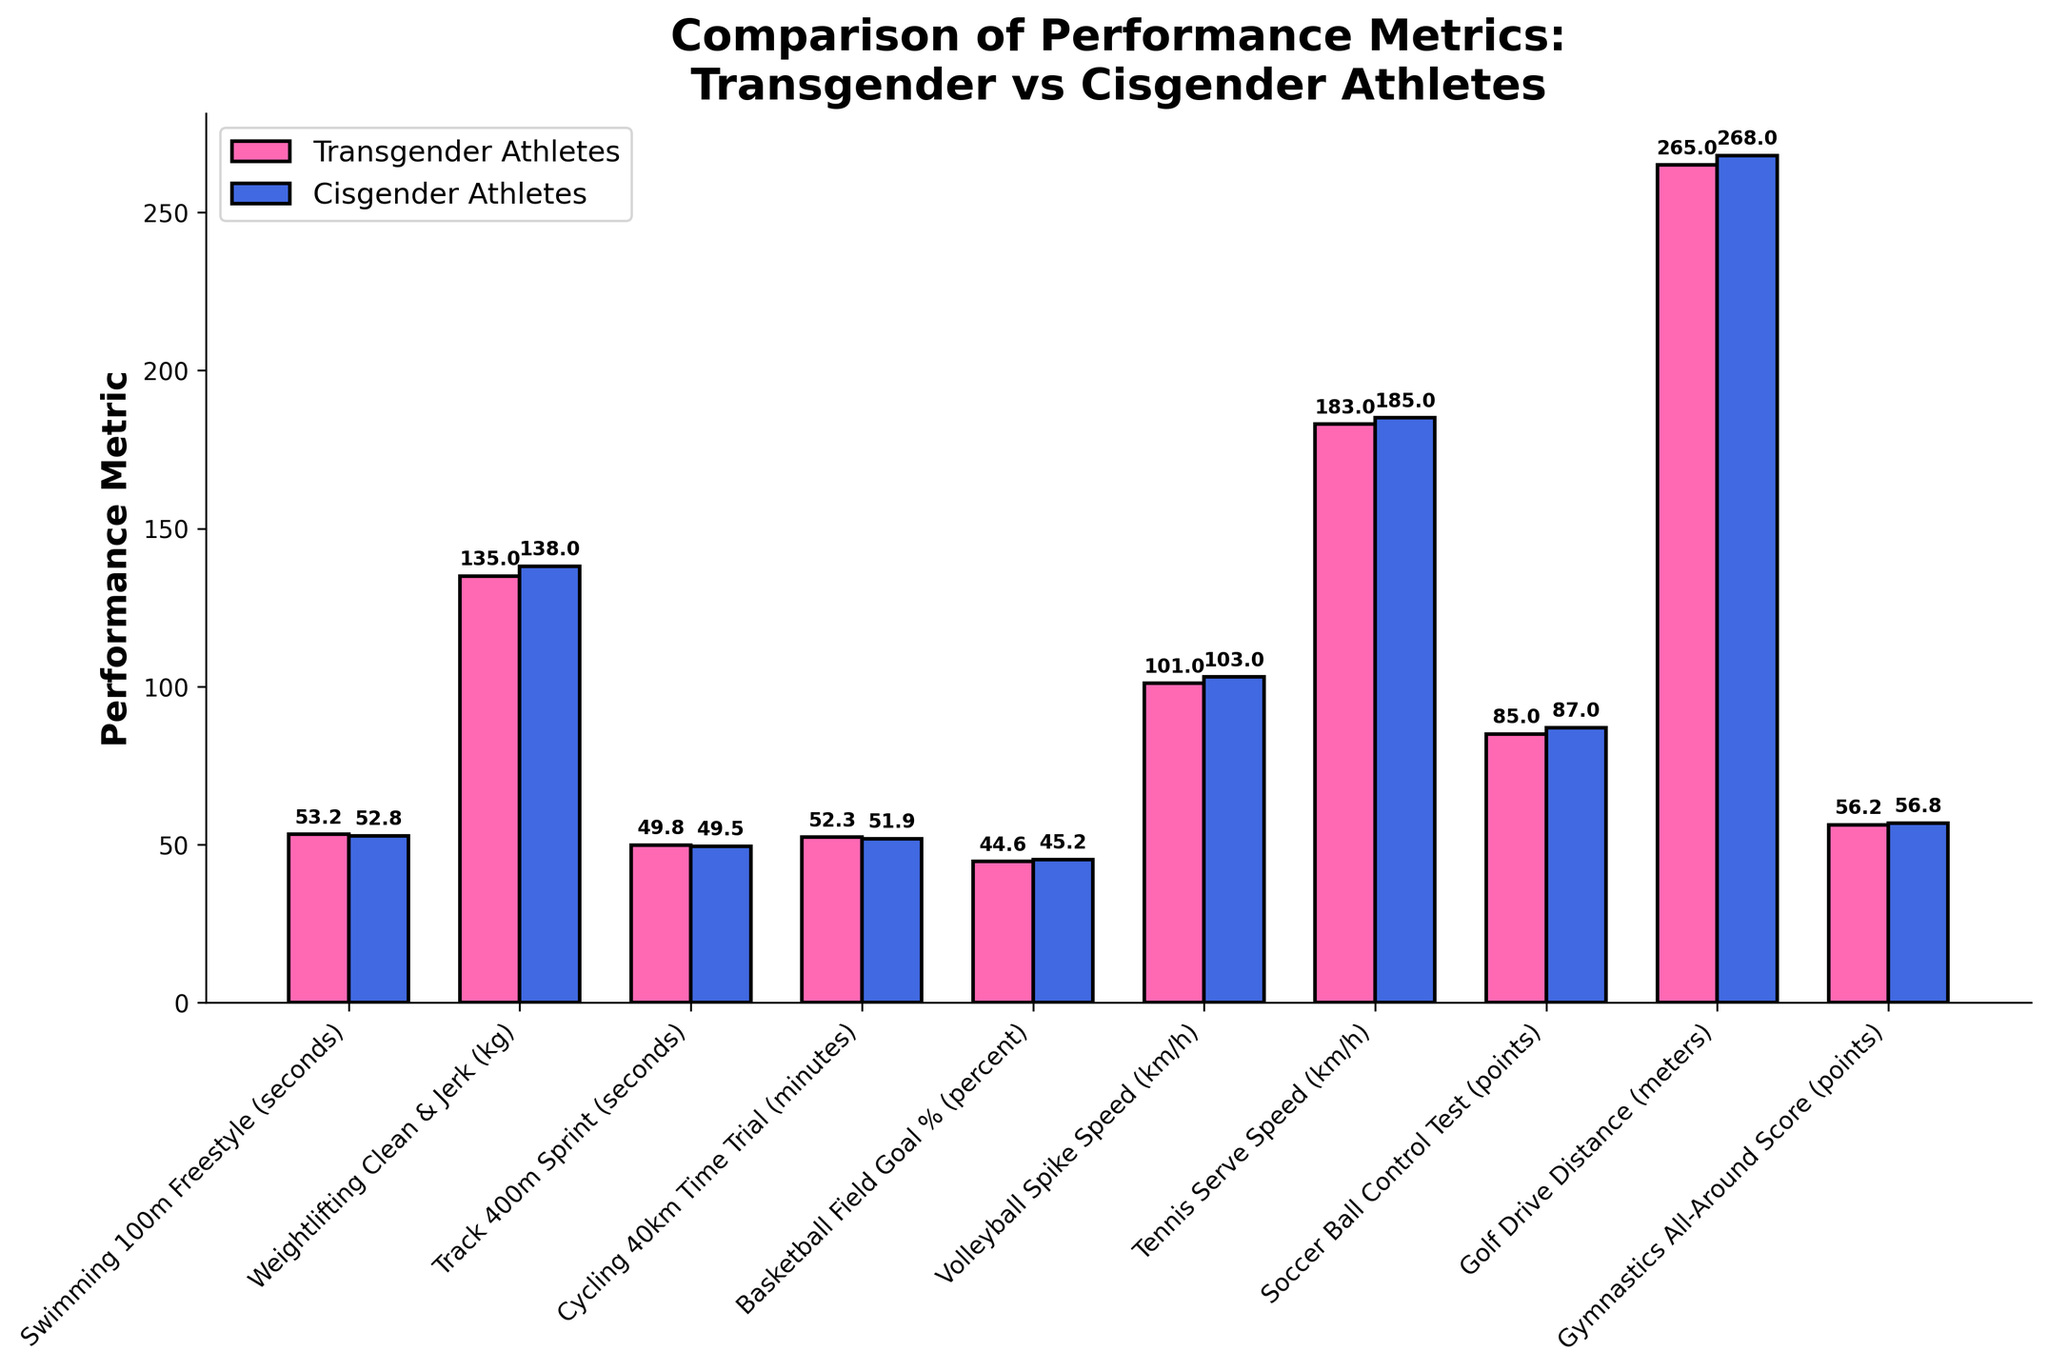What is the difference in average Clean & Jerk weight between transgender and cisgender athletes? The average Clean & Jerk weight for transgender athletes is 135 kg, and for cisgender athletes, it is 138 kg. To find the difference, subtract the average weight for transgender athletes from the average weight for cisgender athletes: 138 - 135 = 3 kg.
Answer: 3 kg Which group performs better in the 100m Freestyle Swimming on average, and by how much? Transgender athletes have an average time of 53.2 seconds, while cisgender athletes have an average time of 52.8 seconds. The smaller the time, the better the performance. Therefore, cisgender athletes perform better by 53.2 - 52.8 = 0.4 seconds.
Answer: Cisgender athletes by 0.4 seconds What is the average spike speed in Volleyball for both groups combined? The average spike speed for transgender athletes is 101 km/h, and for cisgender athletes, it is 103 km/h. To find the overall average, add the two values and divide by 2: (101 + 103) / 2 = 204 / 2 = 102 km/h.
Answer: 102 km/h In which sport is the performance gap between transgender and cisgender athletes the smallest, and what is the gap? Cycling 40km Time Trial has transgender athletes averaging 52.3 minutes and cisgender athletes averaging 51.9 minutes. The performance gap is 52.3 - 51.9 = 0.4 minutes, which is the smallest gap in the dataset.
Answer: Cycling 40km Time Trial by 0.4 minutes Which sport shows the greatest performance advantage for cisgender athletes, and what is the difference? The largest performance difference is in Golf Drive Distance where cisgender athletes achieve an average of 268 meters and transgender athletes 265 meters. The difference is 268 - 265 = 3 meters.
Answer: Golf Drive Distance by 3 meters How much better are cisgender athletes' field goal percentages in Basketball compared to transgender athletes? Cisgender athletes have an average field goal percentage of 45.2%, and transgender athletes have 44.6%. The difference is 45.2 - 44.6 = 0.6%.
Answer: 0.6% What is the sum of points achieved in the Soccer Ball Control Test by both groups? Transgender athletes score 85 points on average and cisgender athletes score 87 points. The sum is 85 + 87 = 172 points.
Answer: 172 points Compare the Gymnastics All-Around Scores for the two groups. Which group has a higher score? Cisgender athletes have an average All-Around Score of 56.8 points while transgender athletes have a score of 56.2 points. Therefore, cisgender athletes have a higher score.
Answer: Cisgender athletes What is the average speed of serves in Tennis for transgender athletes? The bar for transgender athletes' tennis serve speed is marked at 183 km/h.
Answer: 183 km/h Which bar is higher in the Track 400m Sprint, and what does that signify? The bar for cisgender athletes is slightly lower at 49.5 seconds compared to transgender athletes at 49.8 seconds. This indicates that cisgender athletes have a better performance in the Track 400m Sprint.
Answer: Cisgender athletes' bar is higher, signifying better performance 